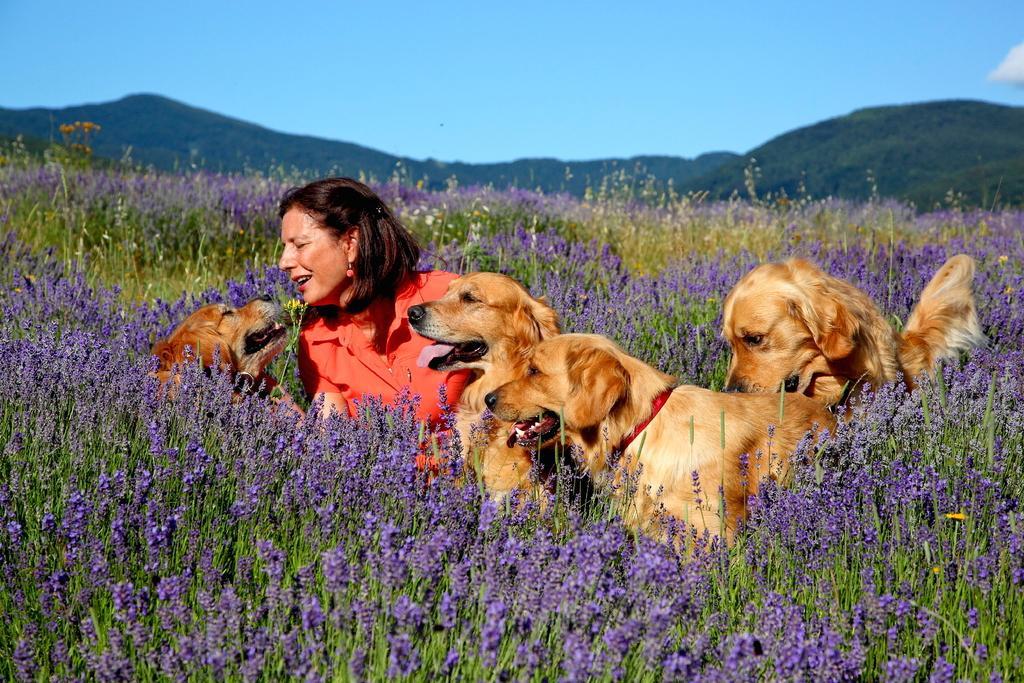Could you give a brief overview of what you see in this image? In this picture there is a woman and we can see dogs, plants and flowers. In the background of the image we can see hills and sky. 